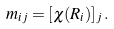Convert formula to latex. <formula><loc_0><loc_0><loc_500><loc_500>{ m } _ { i j } = [ \chi ( R _ { i } ) ] _ { j } \, .</formula> 